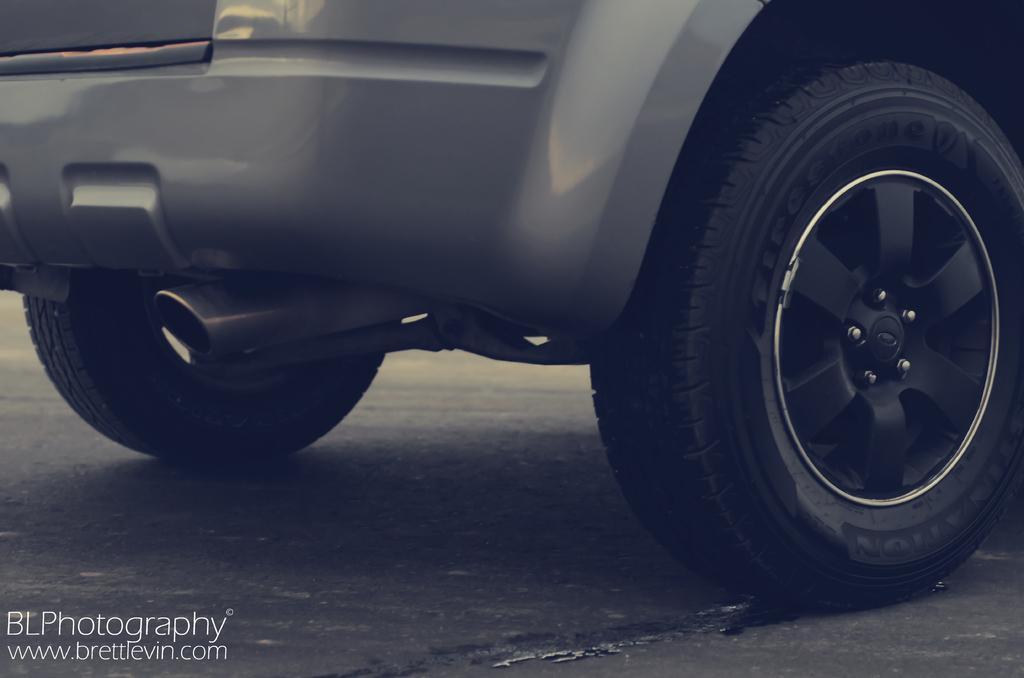Could you give a brief overview of what you see in this image? In this picture it looks like a vehicle, in the bottom left hand side I can see the text. 